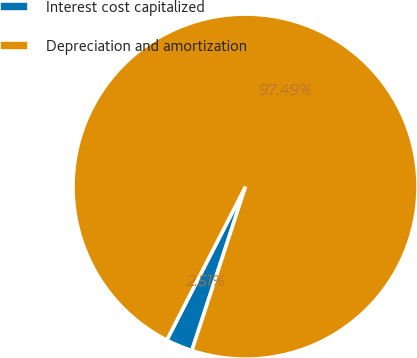<chart> <loc_0><loc_0><loc_500><loc_500><pie_chart><fcel>Interest cost capitalized<fcel>Depreciation and amortization<nl><fcel>2.51%<fcel>97.49%<nl></chart> 